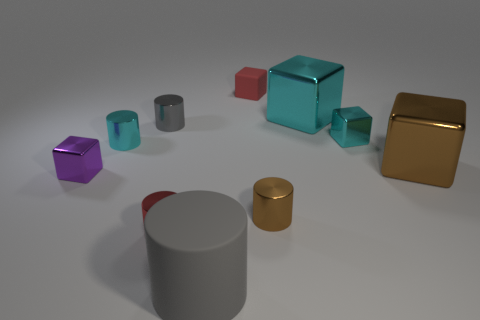Subtract all red cylinders. How many cylinders are left? 4 Subtract all green blocks. How many gray cylinders are left? 2 Subtract all cyan blocks. How many blocks are left? 3 Subtract all yellow cylinders. Subtract all yellow cubes. How many cylinders are left? 5 Subtract all big cyan shiny blocks. Subtract all yellow metal objects. How many objects are left? 9 Add 3 big cyan objects. How many big cyan objects are left? 4 Add 7 big gray cylinders. How many big gray cylinders exist? 8 Subtract 0 cyan spheres. How many objects are left? 10 